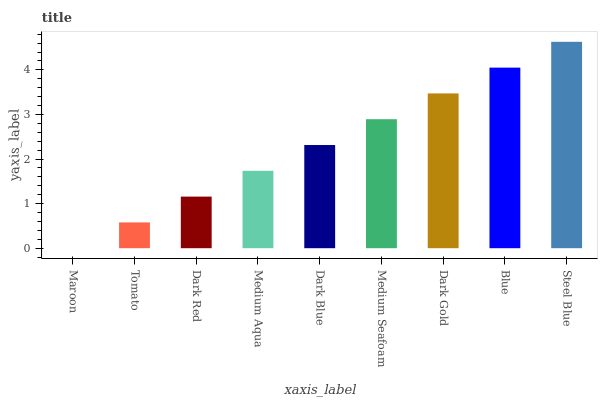Is Maroon the minimum?
Answer yes or no. Yes. Is Steel Blue the maximum?
Answer yes or no. Yes. Is Tomato the minimum?
Answer yes or no. No. Is Tomato the maximum?
Answer yes or no. No. Is Tomato greater than Maroon?
Answer yes or no. Yes. Is Maroon less than Tomato?
Answer yes or no. Yes. Is Maroon greater than Tomato?
Answer yes or no. No. Is Tomato less than Maroon?
Answer yes or no. No. Is Dark Blue the high median?
Answer yes or no. Yes. Is Dark Blue the low median?
Answer yes or no. Yes. Is Dark Gold the high median?
Answer yes or no. No. Is Medium Aqua the low median?
Answer yes or no. No. 